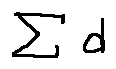<formula> <loc_0><loc_0><loc_500><loc_500>\sum d</formula> 